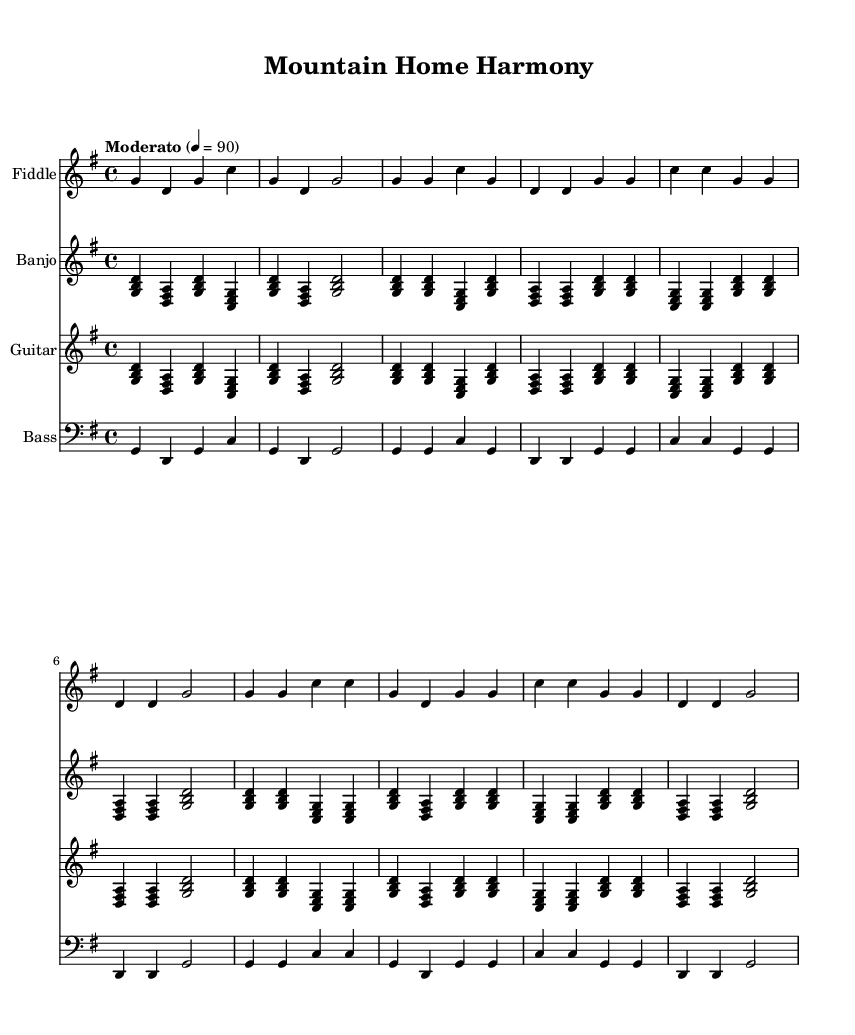What is the key signature of this music? The key signature is G major, which has one sharp (F#). This can be identified by looking at the key signature indicated at the beginning of the score.
Answer: G major What is the time signature of this music? The time signature is 4/4, which means there are four beats in each measure and the quarter note gets one beat. This is typically shown at the beginning, indicating the rhythmic structure of the piece.
Answer: 4/4 What is the tempo marking of the piece? The tempo marking is "Moderato" with a metronome marking of quarter note = 90, indicating a moderate speed at which the piece should be played. This information is presented at the beginning, under the global settings.
Answer: Moderato, 90 How many verses are there in the music? The music contains one verse, as indicated by the structure of the lyrics section where only one lyrical verse is provided before the chorus.
Answer: One Which instruments are featured in this piece? The instruments featured are Fiddle, Banjo, Guitar, and Bass. Each instrument is labeled at the beginning of its respective staff, highlighting the arrangement of the ensemble.
Answer: Fiddle, Banjo, Guitar, Bass What theme is celebrated in the lyrics? The lyrics celebrate family and rural life in Appalachia, emphasizing the values of togetherness and community, which is a common theme in traditional Appalachian folk music. This can be inferred from the content of the lyrics presented.
Answer: Family and rural life What is the title of the piece? The title of the piece is "Mountain Home Harmony," which is displayed at the top of the sheet music. This title reflects the essence of the song, aligning with its themes of rural life and family values.
Answer: Mountain Home Harmony 